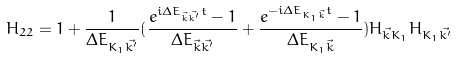<formula> <loc_0><loc_0><loc_500><loc_500>H _ { 2 2 } = 1 + \frac { 1 } { \Delta E _ { { K _ { 1 } } \vec { k ^ { \prime } } } } ( \frac { e ^ { i \Delta E _ { \vec { k } \vec { k ^ { \prime } } } t } - 1 } { \Delta E _ { \vec { k } \vec { k ^ { \prime } } } } + \frac { e ^ { - i \Delta E _ { { K _ { 1 } } \vec { k } } t } - 1 } { \Delta E _ { { K _ { 1 } } \vec { k } } } ) H _ { \vec { k } K _ { 1 } } H _ { K _ { 1 } \vec { k ^ { \prime } } }</formula> 